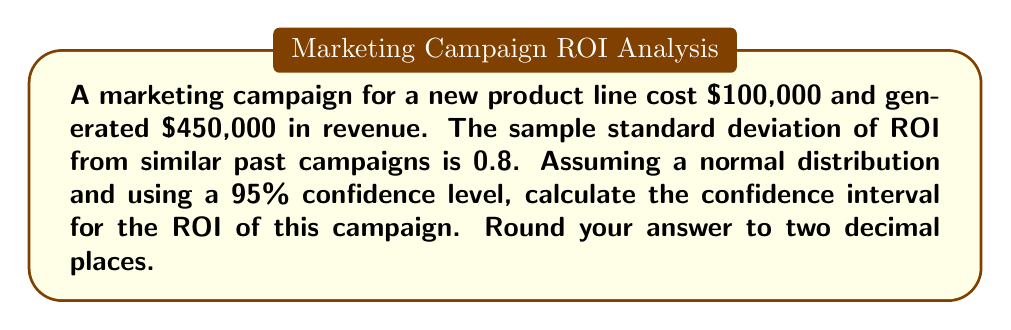Can you answer this question? To calculate the confidence interval for ROI, we'll follow these steps:

1. Calculate the ROI:
   ROI = (Revenue - Cost) / Cost
   ROI = ($450,000 - $100,000) / $100,000 = 3.5 or 350%

2. Determine the critical value for a 95% confidence level:
   For a 95% confidence level, z = 1.96

3. Calculate the standard error:
   We don't have the sample size, so we'll use the standard deviation directly.
   Standard Error (SE) = 0.8

4. Calculate the margin of error:
   Margin of Error = z * SE
   Margin of Error = 1.96 * 0.8 = 1.568

5. Calculate the confidence interval:
   Lower bound = ROI - Margin of Error
   Upper bound = ROI + Margin of Error

   Lower bound = 3.5 - 1.568 = 1.932
   Upper bound = 3.5 + 1.568 = 5.068

6. Convert to percentages and round to two decimal places:
   Lower bound = 193.20%
   Upper bound = 506.80%

Therefore, the 95% confidence interval for the ROI is (193.20%, 506.80%).
Answer: (193.20%, 506.80%) 